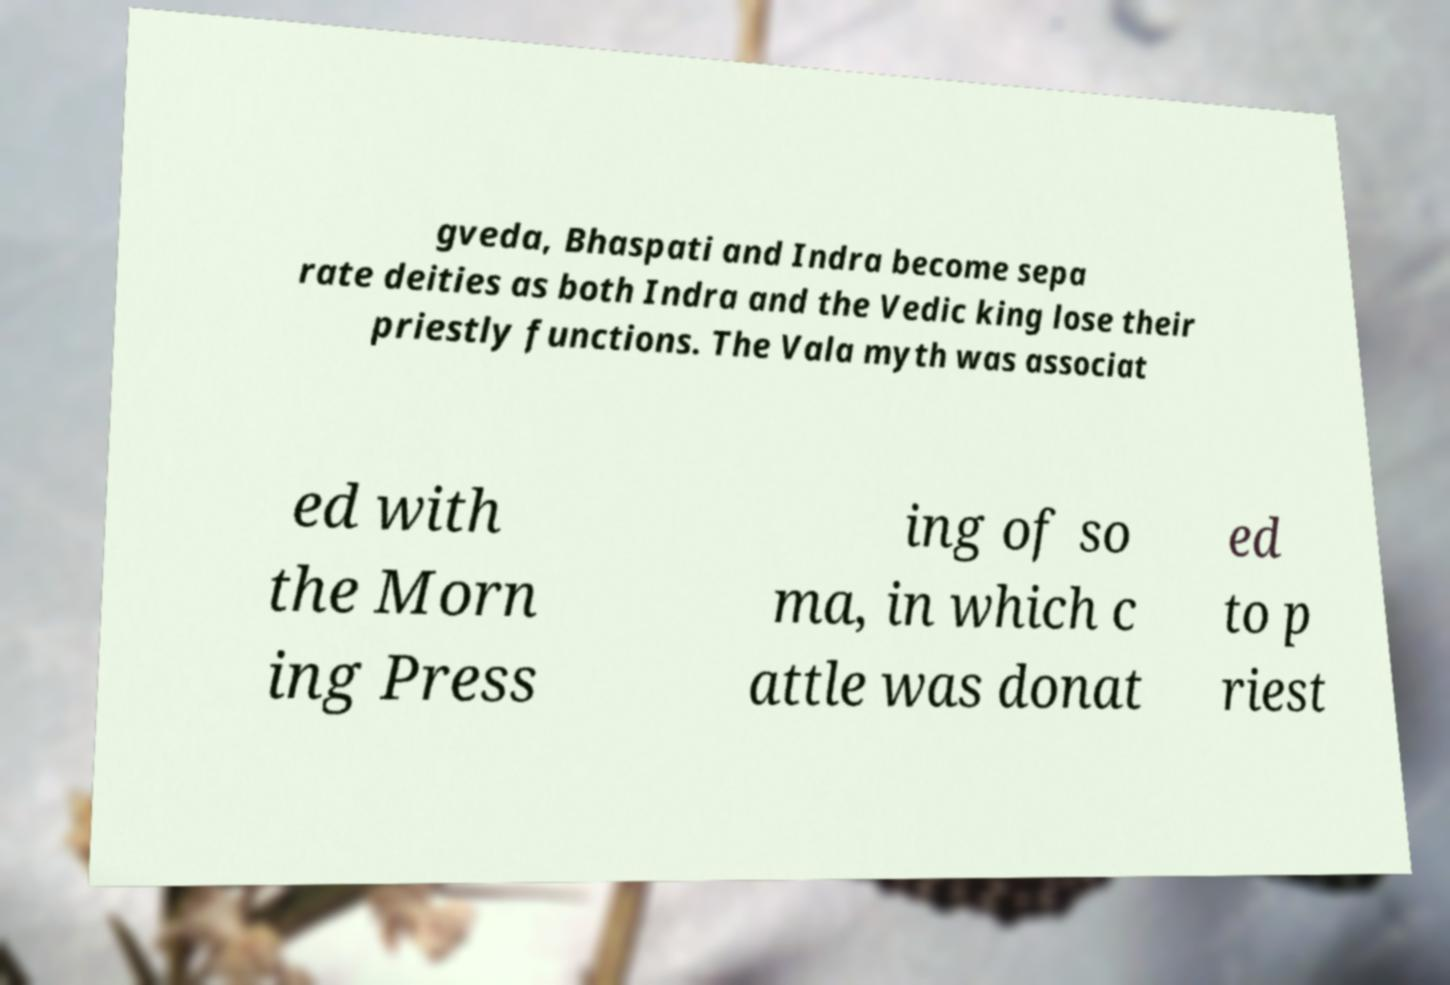There's text embedded in this image that I need extracted. Can you transcribe it verbatim? gveda, Bhaspati and Indra become sepa rate deities as both Indra and the Vedic king lose their priestly functions. The Vala myth was associat ed with the Morn ing Press ing of so ma, in which c attle was donat ed to p riest 